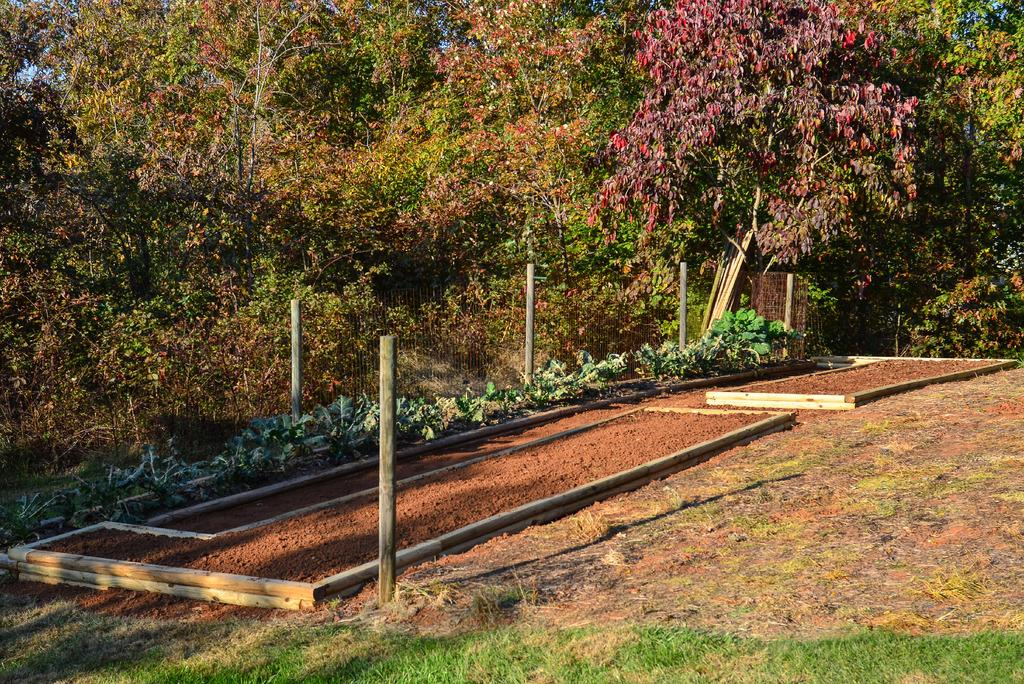What type of surface is on the ground in the image? There is grass on the ground in the image. What can be seen in the background behind the grass? There are wooden poles and trees in the background. What is written or arranged on the ground? There are words arranged on the ground. What part of the natural environment is visible in the image? The sky is visible in the image. Can you tell me how many divisions are present in the airplane in the image? There is no airplane present in the image, so it is not possible to determine the number of divisions. 